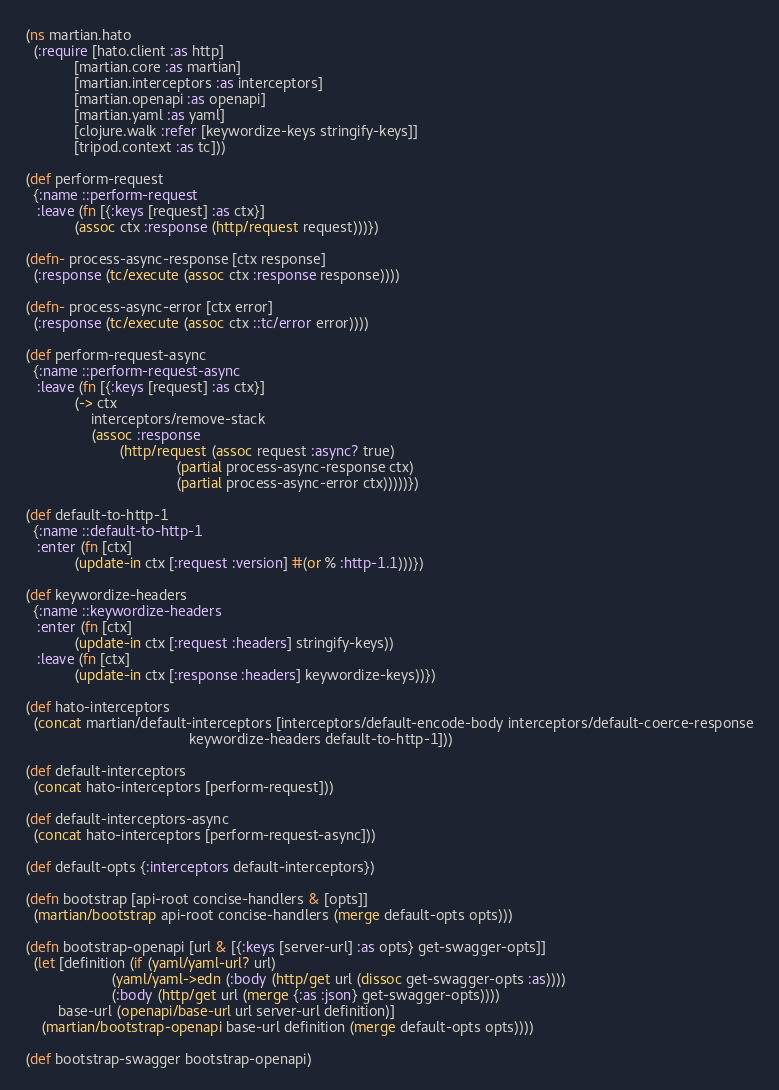Convert code to text. <code><loc_0><loc_0><loc_500><loc_500><_Clojure_>(ns martian.hato
  (:require [hato.client :as http]
            [martian.core :as martian]
            [martian.interceptors :as interceptors]
            [martian.openapi :as openapi]
            [martian.yaml :as yaml]
            [clojure.walk :refer [keywordize-keys stringify-keys]]
            [tripod.context :as tc]))

(def perform-request
  {:name ::perform-request
   :leave (fn [{:keys [request] :as ctx}]
            (assoc ctx :response (http/request request)))})

(defn- process-async-response [ctx response]
  (:response (tc/execute (assoc ctx :response response))))

(defn- process-async-error [ctx error]
  (:response (tc/execute (assoc ctx ::tc/error error))))

(def perform-request-async
  {:name ::perform-request-async
   :leave (fn [{:keys [request] :as ctx}]
            (-> ctx
                interceptors/remove-stack
                (assoc :response
                       (http/request (assoc request :async? true)
                                     (partial process-async-response ctx)
                                     (partial process-async-error ctx)))))})

(def default-to-http-1
  {:name ::default-to-http-1
   :enter (fn [ctx]
            (update-in ctx [:request :version] #(or % :http-1.1)))})

(def keywordize-headers
  {:name ::keywordize-headers
   :enter (fn [ctx]
            (update-in ctx [:request :headers] stringify-keys))
   :leave (fn [ctx]
            (update-in ctx [:response :headers] keywordize-keys))})

(def hato-interceptors
  (concat martian/default-interceptors [interceptors/default-encode-body interceptors/default-coerce-response
                                        keywordize-headers default-to-http-1]))

(def default-interceptors
  (concat hato-interceptors [perform-request]))

(def default-interceptors-async
  (concat hato-interceptors [perform-request-async]))

(def default-opts {:interceptors default-interceptors})

(defn bootstrap [api-root concise-handlers & [opts]]
  (martian/bootstrap api-root concise-handlers (merge default-opts opts)))

(defn bootstrap-openapi [url & [{:keys [server-url] :as opts} get-swagger-opts]]
  (let [definition (if (yaml/yaml-url? url)
                     (yaml/yaml->edn (:body (http/get url (dissoc get-swagger-opts :as))))
                     (:body (http/get url (merge {:as :json} get-swagger-opts))))
        base-url (openapi/base-url url server-url definition)]
    (martian/bootstrap-openapi base-url definition (merge default-opts opts))))

(def bootstrap-swagger bootstrap-openapi)
</code> 